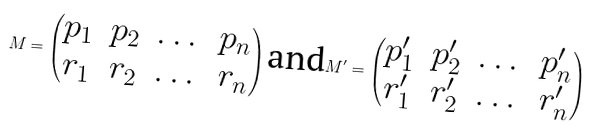Convert formula to latex. <formula><loc_0><loc_0><loc_500><loc_500>M = \begin{pmatrix} p _ { 1 } & p _ { 2 } & \dots & p _ { n } \\ r _ { 1 } & r _ { 2 } & \dots & r _ { n } \end{pmatrix} \text {and} M ^ { \prime } = \begin{pmatrix} p _ { 1 } ^ { \prime } & p _ { 2 } ^ { \prime } & \dots & p _ { n } ^ { \prime } \\ r _ { 1 } ^ { \prime } & r _ { 2 } ^ { \prime } & \dots & r _ { n } ^ { \prime } \end{pmatrix}</formula> 